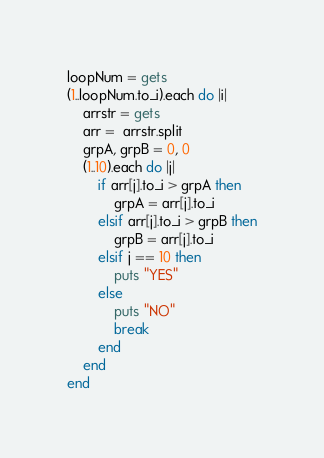Convert code to text. <code><loc_0><loc_0><loc_500><loc_500><_Ruby_>loopNum = gets
(1..loopNum.to_i).each do |i|
	arrstr = gets
	arr =  arrstr.split
	grpA, grpB = 0, 0
	(1..10).each do |j|
		if arr[j].to_i > grpA then
			grpA = arr[j].to_i
		elsif arr[j].to_i > grpB then
			grpB = arr[j].to_i
		elsif j == 10 then
			puts "YES"
		else
			puts "NO"
			break
		end
	end
end</code> 